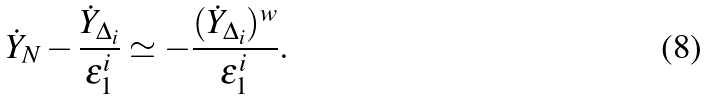<formula> <loc_0><loc_0><loc_500><loc_500>\dot { Y } _ { N } - \frac { \dot { Y } _ { \Delta _ { i } } } { \varepsilon ^ { i } _ { 1 } } \simeq - \frac { ( \dot { Y } _ { \Delta _ { i } } ) ^ { w } } { \varepsilon ^ { i } _ { 1 } } .</formula> 